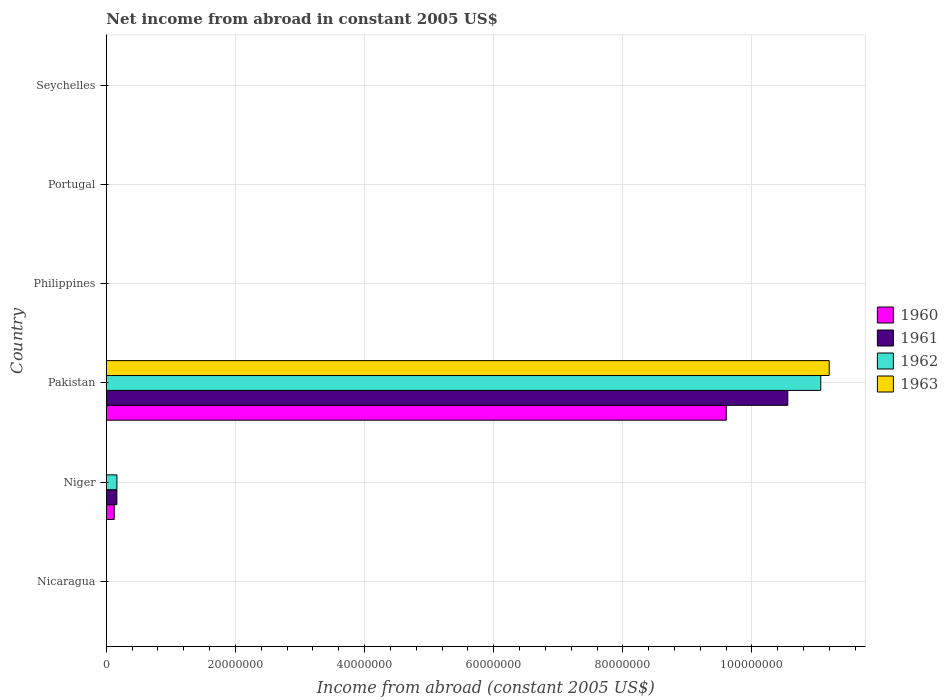How many different coloured bars are there?
Offer a terse response. 4. Are the number of bars per tick equal to the number of legend labels?
Ensure brevity in your answer.  No. Are the number of bars on each tick of the Y-axis equal?
Offer a very short reply. No. What is the label of the 5th group of bars from the top?
Offer a very short reply. Niger. In how many cases, is the number of bars for a given country not equal to the number of legend labels?
Keep it short and to the point. 5. What is the net income from abroad in 1960 in Portugal?
Give a very brief answer. 0. Across all countries, what is the maximum net income from abroad in 1960?
Ensure brevity in your answer.  9.60e+07. What is the total net income from abroad in 1961 in the graph?
Offer a terse response. 1.07e+08. What is the difference between the net income from abroad in 1960 in Niger and that in Pakistan?
Give a very brief answer. -9.48e+07. What is the difference between the net income from abroad in 1960 in Niger and the net income from abroad in 1963 in Philippines?
Your answer should be very brief. 1.22e+06. What is the average net income from abroad in 1962 per country?
Offer a very short reply. 1.87e+07. What is the difference between the net income from abroad in 1962 and net income from abroad in 1960 in Pakistan?
Provide a succinct answer. 1.46e+07. Is the difference between the net income from abroad in 1962 in Niger and Pakistan greater than the difference between the net income from abroad in 1960 in Niger and Pakistan?
Ensure brevity in your answer.  No. What is the difference between the highest and the lowest net income from abroad in 1961?
Offer a very short reply. 1.06e+08. In how many countries, is the net income from abroad in 1961 greater than the average net income from abroad in 1961 taken over all countries?
Provide a succinct answer. 1. Is it the case that in every country, the sum of the net income from abroad in 1962 and net income from abroad in 1963 is greater than the sum of net income from abroad in 1961 and net income from abroad in 1960?
Offer a very short reply. No. How many bars are there?
Your answer should be very brief. 7. How many countries are there in the graph?
Offer a terse response. 6. Does the graph contain any zero values?
Give a very brief answer. Yes. Does the graph contain grids?
Your answer should be very brief. Yes. How are the legend labels stacked?
Provide a short and direct response. Vertical. What is the title of the graph?
Your response must be concise. Net income from abroad in constant 2005 US$. What is the label or title of the X-axis?
Keep it short and to the point. Income from abroad (constant 2005 US$). What is the Income from abroad (constant 2005 US$) of 1961 in Nicaragua?
Ensure brevity in your answer.  0. What is the Income from abroad (constant 2005 US$) of 1960 in Niger?
Offer a very short reply. 1.22e+06. What is the Income from abroad (constant 2005 US$) of 1961 in Niger?
Make the answer very short. 1.63e+06. What is the Income from abroad (constant 2005 US$) of 1962 in Niger?
Your response must be concise. 1.64e+06. What is the Income from abroad (constant 2005 US$) in 1963 in Niger?
Make the answer very short. 0. What is the Income from abroad (constant 2005 US$) in 1960 in Pakistan?
Give a very brief answer. 9.60e+07. What is the Income from abroad (constant 2005 US$) of 1961 in Pakistan?
Offer a very short reply. 1.06e+08. What is the Income from abroad (constant 2005 US$) in 1962 in Pakistan?
Provide a short and direct response. 1.11e+08. What is the Income from abroad (constant 2005 US$) in 1963 in Pakistan?
Offer a terse response. 1.12e+08. What is the Income from abroad (constant 2005 US$) in 1960 in Philippines?
Offer a very short reply. 0. What is the Income from abroad (constant 2005 US$) in 1961 in Philippines?
Offer a very short reply. 0. What is the Income from abroad (constant 2005 US$) of 1962 in Philippines?
Provide a succinct answer. 0. What is the Income from abroad (constant 2005 US$) in 1963 in Philippines?
Give a very brief answer. 0. What is the Income from abroad (constant 2005 US$) in 1960 in Portugal?
Keep it short and to the point. 0. What is the Income from abroad (constant 2005 US$) of 1963 in Portugal?
Provide a succinct answer. 0. What is the Income from abroad (constant 2005 US$) of 1960 in Seychelles?
Give a very brief answer. 0. What is the Income from abroad (constant 2005 US$) in 1962 in Seychelles?
Provide a succinct answer. 0. Across all countries, what is the maximum Income from abroad (constant 2005 US$) in 1960?
Your answer should be very brief. 9.60e+07. Across all countries, what is the maximum Income from abroad (constant 2005 US$) of 1961?
Provide a succinct answer. 1.06e+08. Across all countries, what is the maximum Income from abroad (constant 2005 US$) in 1962?
Give a very brief answer. 1.11e+08. Across all countries, what is the maximum Income from abroad (constant 2005 US$) of 1963?
Your response must be concise. 1.12e+08. Across all countries, what is the minimum Income from abroad (constant 2005 US$) of 1961?
Your response must be concise. 0. Across all countries, what is the minimum Income from abroad (constant 2005 US$) of 1962?
Keep it short and to the point. 0. Across all countries, what is the minimum Income from abroad (constant 2005 US$) in 1963?
Your answer should be compact. 0. What is the total Income from abroad (constant 2005 US$) in 1960 in the graph?
Your answer should be compact. 9.72e+07. What is the total Income from abroad (constant 2005 US$) in 1961 in the graph?
Offer a terse response. 1.07e+08. What is the total Income from abroad (constant 2005 US$) of 1962 in the graph?
Offer a terse response. 1.12e+08. What is the total Income from abroad (constant 2005 US$) in 1963 in the graph?
Provide a short and direct response. 1.12e+08. What is the difference between the Income from abroad (constant 2005 US$) of 1960 in Niger and that in Pakistan?
Provide a short and direct response. -9.48e+07. What is the difference between the Income from abroad (constant 2005 US$) of 1961 in Niger and that in Pakistan?
Your answer should be compact. -1.04e+08. What is the difference between the Income from abroad (constant 2005 US$) of 1962 in Niger and that in Pakistan?
Provide a short and direct response. -1.09e+08. What is the difference between the Income from abroad (constant 2005 US$) in 1960 in Niger and the Income from abroad (constant 2005 US$) in 1961 in Pakistan?
Your answer should be compact. -1.04e+08. What is the difference between the Income from abroad (constant 2005 US$) in 1960 in Niger and the Income from abroad (constant 2005 US$) in 1962 in Pakistan?
Offer a very short reply. -1.09e+08. What is the difference between the Income from abroad (constant 2005 US$) of 1960 in Niger and the Income from abroad (constant 2005 US$) of 1963 in Pakistan?
Offer a very short reply. -1.11e+08. What is the difference between the Income from abroad (constant 2005 US$) in 1961 in Niger and the Income from abroad (constant 2005 US$) in 1962 in Pakistan?
Provide a succinct answer. -1.09e+08. What is the difference between the Income from abroad (constant 2005 US$) in 1961 in Niger and the Income from abroad (constant 2005 US$) in 1963 in Pakistan?
Your answer should be very brief. -1.10e+08. What is the difference between the Income from abroad (constant 2005 US$) of 1962 in Niger and the Income from abroad (constant 2005 US$) of 1963 in Pakistan?
Your answer should be compact. -1.10e+08. What is the average Income from abroad (constant 2005 US$) of 1960 per country?
Offer a very short reply. 1.62e+07. What is the average Income from abroad (constant 2005 US$) in 1961 per country?
Your answer should be very brief. 1.79e+07. What is the average Income from abroad (constant 2005 US$) in 1962 per country?
Provide a succinct answer. 1.87e+07. What is the average Income from abroad (constant 2005 US$) in 1963 per country?
Your response must be concise. 1.87e+07. What is the difference between the Income from abroad (constant 2005 US$) in 1960 and Income from abroad (constant 2005 US$) in 1961 in Niger?
Keep it short and to the point. -4.08e+05. What is the difference between the Income from abroad (constant 2005 US$) of 1960 and Income from abroad (constant 2005 US$) of 1962 in Niger?
Provide a short and direct response. -4.13e+05. What is the difference between the Income from abroad (constant 2005 US$) of 1961 and Income from abroad (constant 2005 US$) of 1962 in Niger?
Your answer should be very brief. -5017.31. What is the difference between the Income from abroad (constant 2005 US$) of 1960 and Income from abroad (constant 2005 US$) of 1961 in Pakistan?
Give a very brief answer. -9.53e+06. What is the difference between the Income from abroad (constant 2005 US$) in 1960 and Income from abroad (constant 2005 US$) in 1962 in Pakistan?
Offer a terse response. -1.46e+07. What is the difference between the Income from abroad (constant 2005 US$) in 1960 and Income from abroad (constant 2005 US$) in 1963 in Pakistan?
Offer a very short reply. -1.59e+07. What is the difference between the Income from abroad (constant 2005 US$) in 1961 and Income from abroad (constant 2005 US$) in 1962 in Pakistan?
Ensure brevity in your answer.  -5.11e+06. What is the difference between the Income from abroad (constant 2005 US$) of 1961 and Income from abroad (constant 2005 US$) of 1963 in Pakistan?
Keep it short and to the point. -6.42e+06. What is the difference between the Income from abroad (constant 2005 US$) of 1962 and Income from abroad (constant 2005 US$) of 1963 in Pakistan?
Ensure brevity in your answer.  -1.31e+06. What is the ratio of the Income from abroad (constant 2005 US$) of 1960 in Niger to that in Pakistan?
Give a very brief answer. 0.01. What is the ratio of the Income from abroad (constant 2005 US$) in 1961 in Niger to that in Pakistan?
Ensure brevity in your answer.  0.02. What is the ratio of the Income from abroad (constant 2005 US$) in 1962 in Niger to that in Pakistan?
Provide a succinct answer. 0.01. What is the difference between the highest and the lowest Income from abroad (constant 2005 US$) of 1960?
Give a very brief answer. 9.60e+07. What is the difference between the highest and the lowest Income from abroad (constant 2005 US$) of 1961?
Provide a succinct answer. 1.06e+08. What is the difference between the highest and the lowest Income from abroad (constant 2005 US$) in 1962?
Ensure brevity in your answer.  1.11e+08. What is the difference between the highest and the lowest Income from abroad (constant 2005 US$) in 1963?
Ensure brevity in your answer.  1.12e+08. 